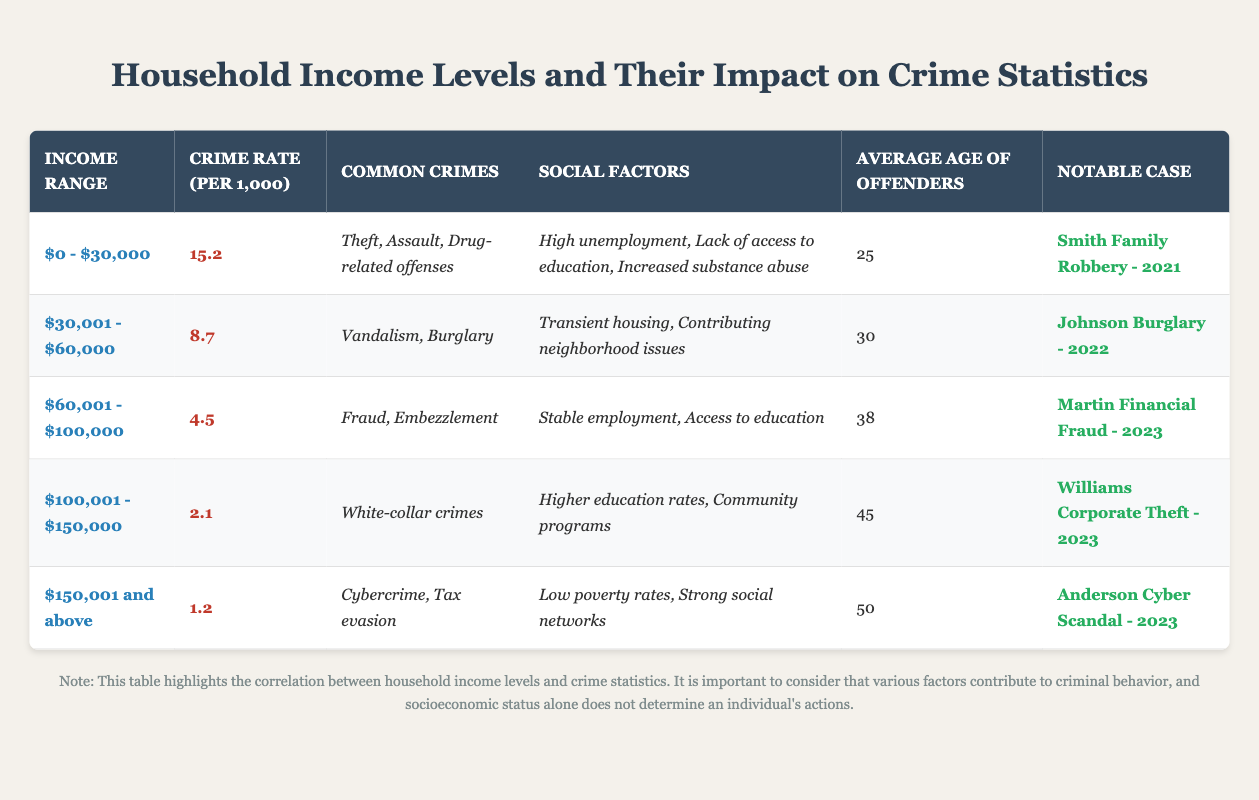What is the crime rate per 1,000 for households earning between $0 and $30,000? According to the table, the crime rate for the income range of $0 - $30,000 is explicitly stated as 15.2 per 1,000.
Answer: 15.2 What are the common crimes listed for the income range of $30,001 - $60,000? The table specifies that the common crimes for this income range are vandalism and burglary.
Answer: Vandalism, Burglary What is the average age of offenders for the highest income range? The table shows that for the income range of $150,001 and above, the average age of offenders is 50.
Answer: 50 Are drug-related offenses more common in low-income households? The common crimes listed for households earning $0 - $30,000 include drug-related offenses, while higher income brackets do not list them. This suggests they are indeed more prevalent in lower-income households.
Answer: Yes What social factors are associated with the income range of $60,001 - $100,000? The table states that for this income range, social factors include stable employment and access to education.
Answer: Stable employment, Access to education If we compare the crime rates of the $0 - $30,000 and $100,001 - $150,000 income ranges, how much lower is the crime rate for the higher income range? The crime rate for the $0 - $30,000 range is 15.2, while for $100,001 - $150,000 it is 2.1. The difference is 15.2 - 2.1 = 13.1, indicating a significant reduction.
Answer: 13.1 What notable case corresponds to the income range of $150,001 and above? The table lists "Anderson Cyber Scandal - 2023" as the notable case for this income level.
Answer: Anderson Cyber Scandal - 2023 Is there a trend in crime rates as income increases? The data shows that as income levels increase, the crime rates consistently decrease from 15.2 to 1.2. This indicates a clear trend of lower crime rates with increasing income levels.
Answer: Yes Which income range has the highest crime rate per 1,000? By comparing the crime rates in the table, the income range of $0 - $30,000 has the highest rate at 15.2 per 1,000.
Answer: $0 - $30,000 Where does the average age of offenders appear to peak, based on the data? The average age of offenders increases with income levels, peaking at age 50 for the income range of $150,001 and above.
Answer: $150,001 and above What could be inferred about the connection between education access and crime rates from the table? The table implies that access to education correlates with lower crime rates, as seen in higher income ranges (e.g., $60,001 - $100,000) and their associated lower crime rates.
Answer: Access to education reduces crime rates 